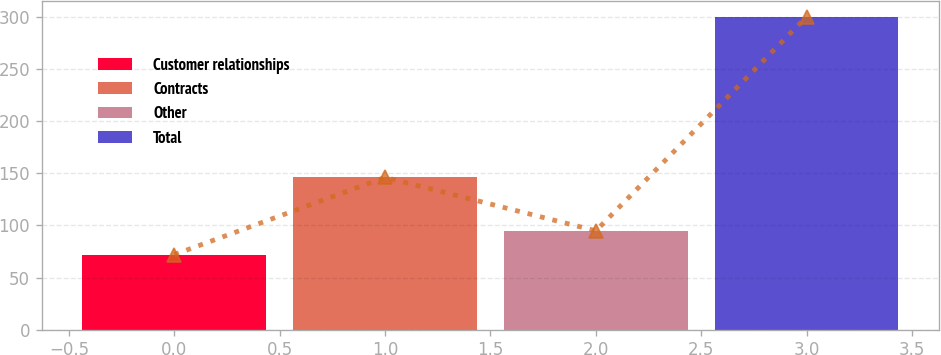Convert chart to OTSL. <chart><loc_0><loc_0><loc_500><loc_500><bar_chart><fcel>Customer relationships<fcel>Contracts<fcel>Other<fcel>Total<nl><fcel>72<fcel>146<fcel>94.8<fcel>300<nl></chart> 